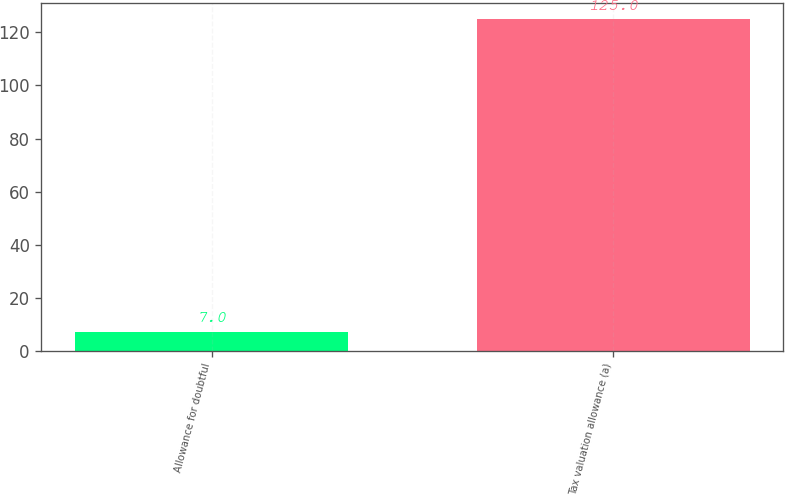Convert chart to OTSL. <chart><loc_0><loc_0><loc_500><loc_500><bar_chart><fcel>Allowance for doubtful<fcel>Tax valuation allowance (a)<nl><fcel>7<fcel>125<nl></chart> 